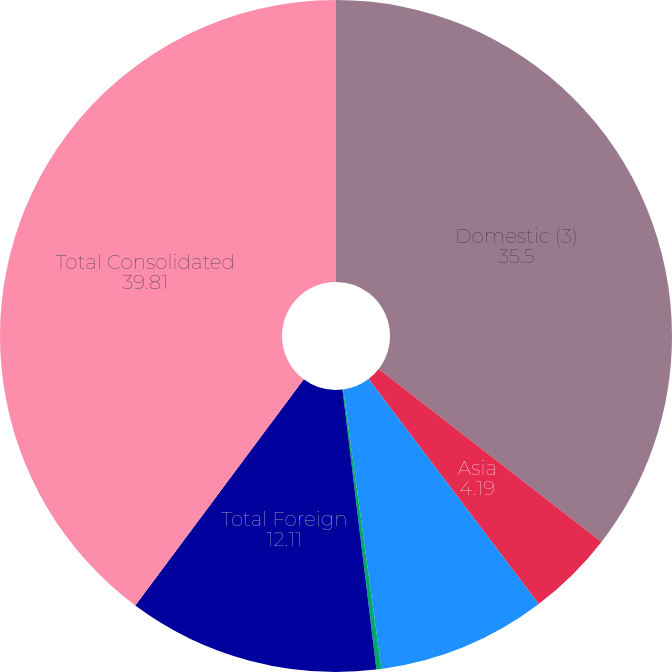Convert chart. <chart><loc_0><loc_0><loc_500><loc_500><pie_chart><fcel>Domestic (3)<fcel>Asia<fcel>Europe Middle East and Africa<fcel>Latin America and the<fcel>Total Foreign<fcel>Total Consolidated<nl><fcel>35.5%<fcel>4.19%<fcel>8.15%<fcel>0.24%<fcel>12.11%<fcel>39.81%<nl></chart> 